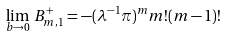<formula> <loc_0><loc_0><loc_500><loc_500>\lim _ { b \rightarrow 0 } \, B ^ { + } _ { m , 1 } = - ( \lambda ^ { - 1 } \pi ) ^ { m } m ! ( m - 1 ) !</formula> 